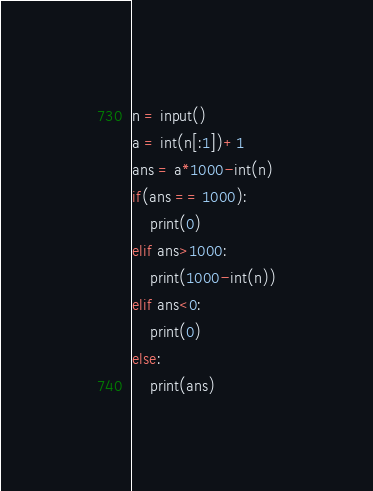Convert code to text. <code><loc_0><loc_0><loc_500><loc_500><_Python_>n = input()
a = int(n[:1])+1
ans = a*1000-int(n)
if(ans == 1000):
    print(0)
elif ans>1000:
    print(1000-int(n))
elif ans<0:
    print(0)
else:
    print(ans)</code> 